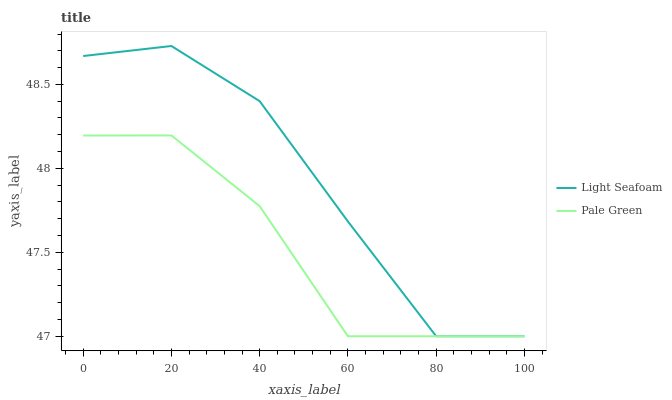Does Pale Green have the minimum area under the curve?
Answer yes or no. Yes. Does Light Seafoam have the maximum area under the curve?
Answer yes or no. Yes. Does Light Seafoam have the minimum area under the curve?
Answer yes or no. No. Is Light Seafoam the smoothest?
Answer yes or no. Yes. Is Pale Green the roughest?
Answer yes or no. Yes. Is Light Seafoam the roughest?
Answer yes or no. No. Does Pale Green have the lowest value?
Answer yes or no. Yes. Does Light Seafoam have the highest value?
Answer yes or no. Yes. Does Pale Green intersect Light Seafoam?
Answer yes or no. Yes. Is Pale Green less than Light Seafoam?
Answer yes or no. No. Is Pale Green greater than Light Seafoam?
Answer yes or no. No. 